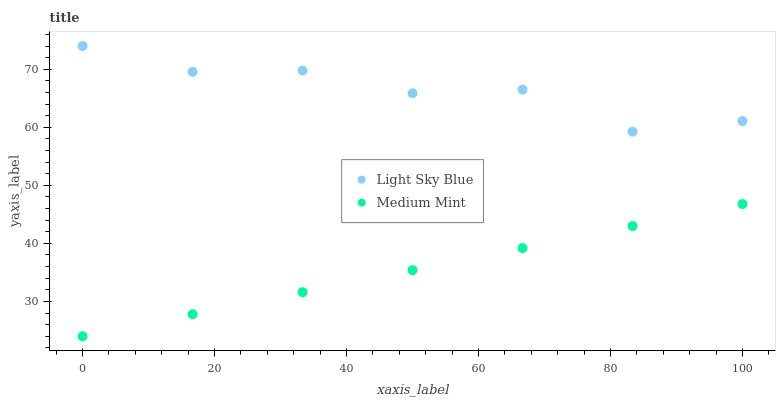Does Medium Mint have the minimum area under the curve?
Answer yes or no. Yes. Does Light Sky Blue have the maximum area under the curve?
Answer yes or no. Yes. Does Light Sky Blue have the minimum area under the curve?
Answer yes or no. No. Is Medium Mint the smoothest?
Answer yes or no. Yes. Is Light Sky Blue the roughest?
Answer yes or no. Yes. Is Light Sky Blue the smoothest?
Answer yes or no. No. Does Medium Mint have the lowest value?
Answer yes or no. Yes. Does Light Sky Blue have the lowest value?
Answer yes or no. No. Does Light Sky Blue have the highest value?
Answer yes or no. Yes. Is Medium Mint less than Light Sky Blue?
Answer yes or no. Yes. Is Light Sky Blue greater than Medium Mint?
Answer yes or no. Yes. Does Medium Mint intersect Light Sky Blue?
Answer yes or no. No. 